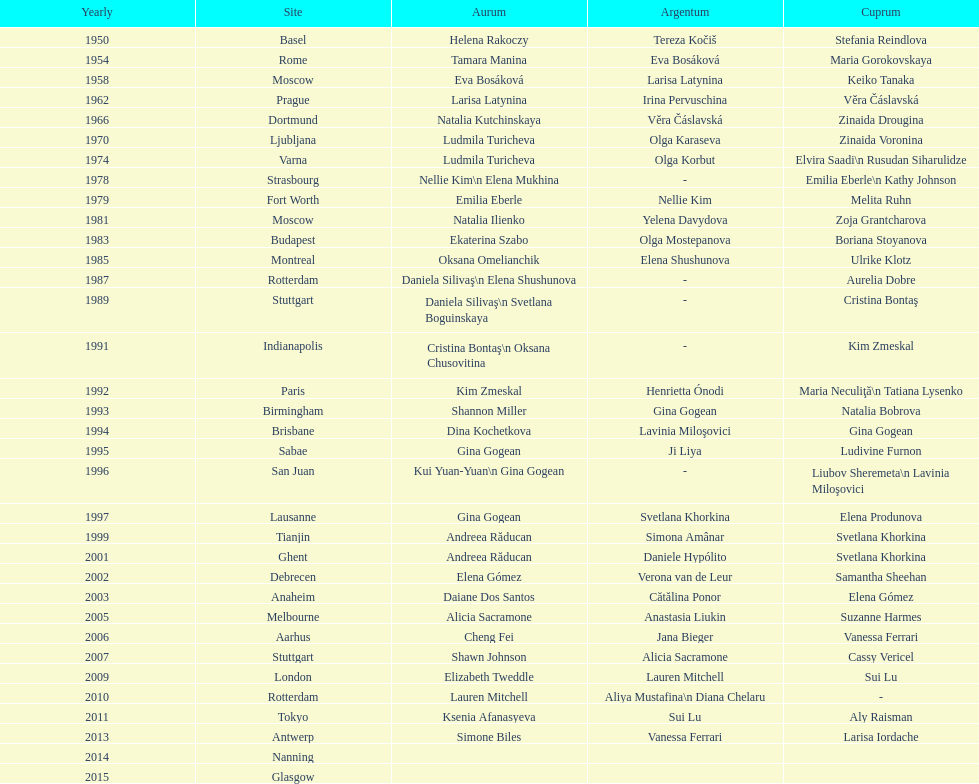As of 2013, what is the total number of floor exercise gold medals won by american women at the world championships? 5. 